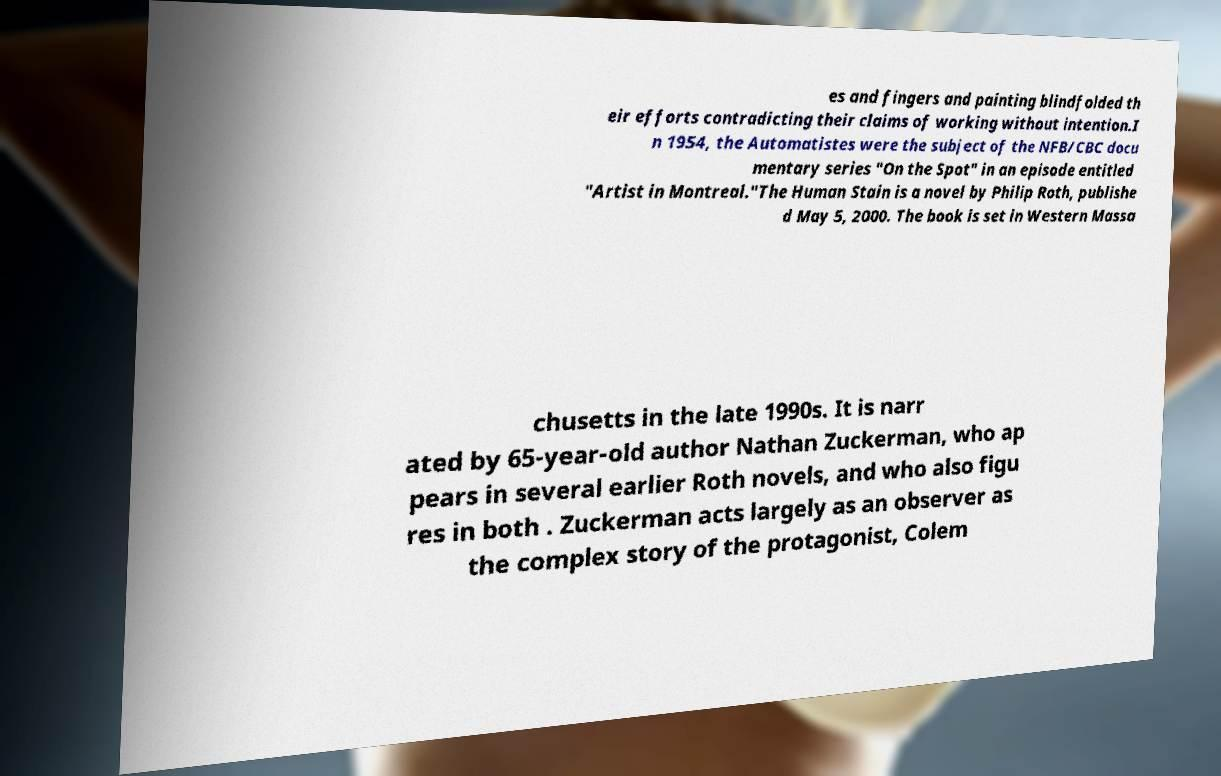Can you read and provide the text displayed in the image?This photo seems to have some interesting text. Can you extract and type it out for me? es and fingers and painting blindfolded th eir efforts contradicting their claims of working without intention.I n 1954, the Automatistes were the subject of the NFB/CBC docu mentary series "On the Spot" in an episode entitled "Artist in Montreal."The Human Stain is a novel by Philip Roth, publishe d May 5, 2000. The book is set in Western Massa chusetts in the late 1990s. It is narr ated by 65-year-old author Nathan Zuckerman, who ap pears in several earlier Roth novels, and who also figu res in both . Zuckerman acts largely as an observer as the complex story of the protagonist, Colem 